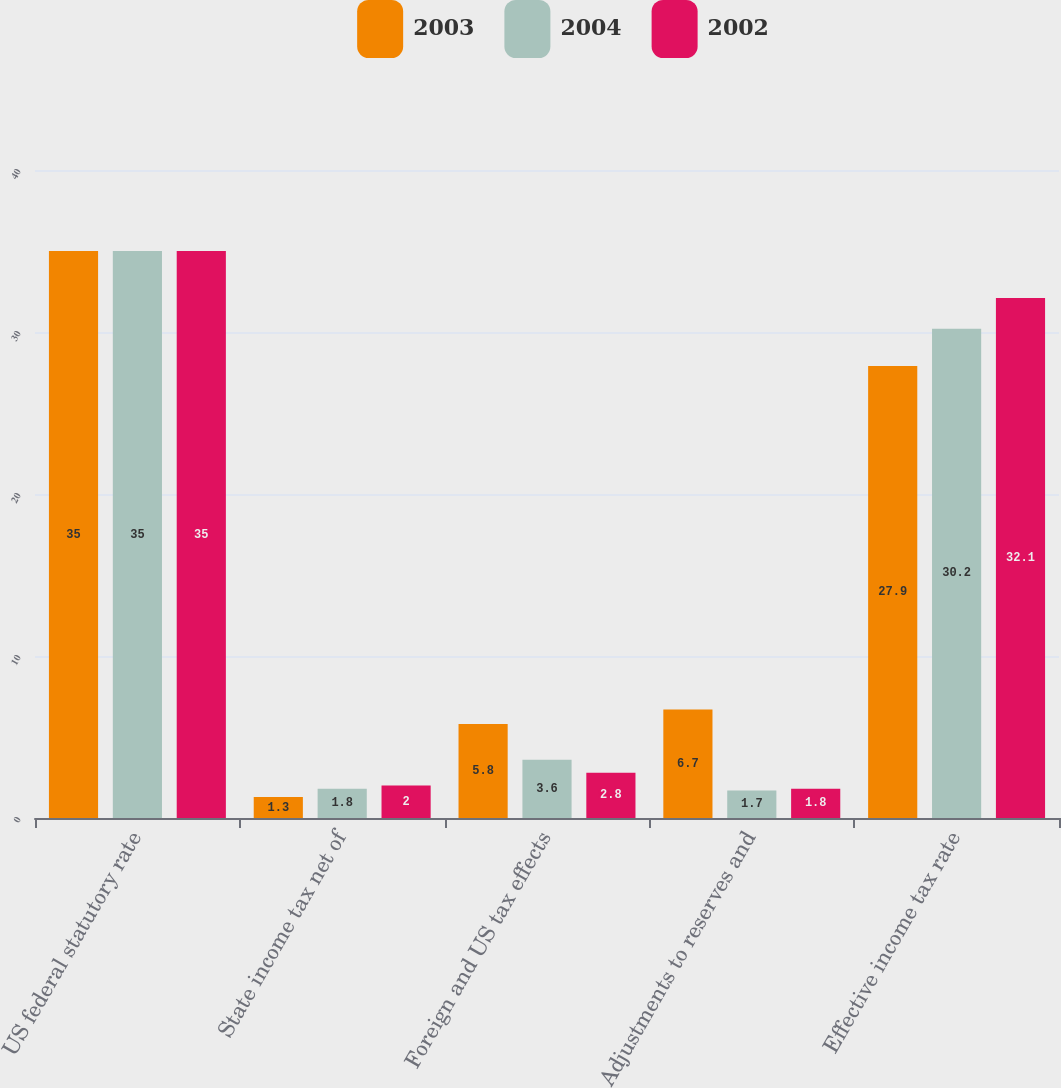<chart> <loc_0><loc_0><loc_500><loc_500><stacked_bar_chart><ecel><fcel>US federal statutory rate<fcel>State income tax net of<fcel>Foreign and US tax effects<fcel>Adjustments to reserves and<fcel>Effective income tax rate<nl><fcel>2003<fcel>35<fcel>1.3<fcel>5.8<fcel>6.7<fcel>27.9<nl><fcel>2004<fcel>35<fcel>1.8<fcel>3.6<fcel>1.7<fcel>30.2<nl><fcel>2002<fcel>35<fcel>2<fcel>2.8<fcel>1.8<fcel>32.1<nl></chart> 